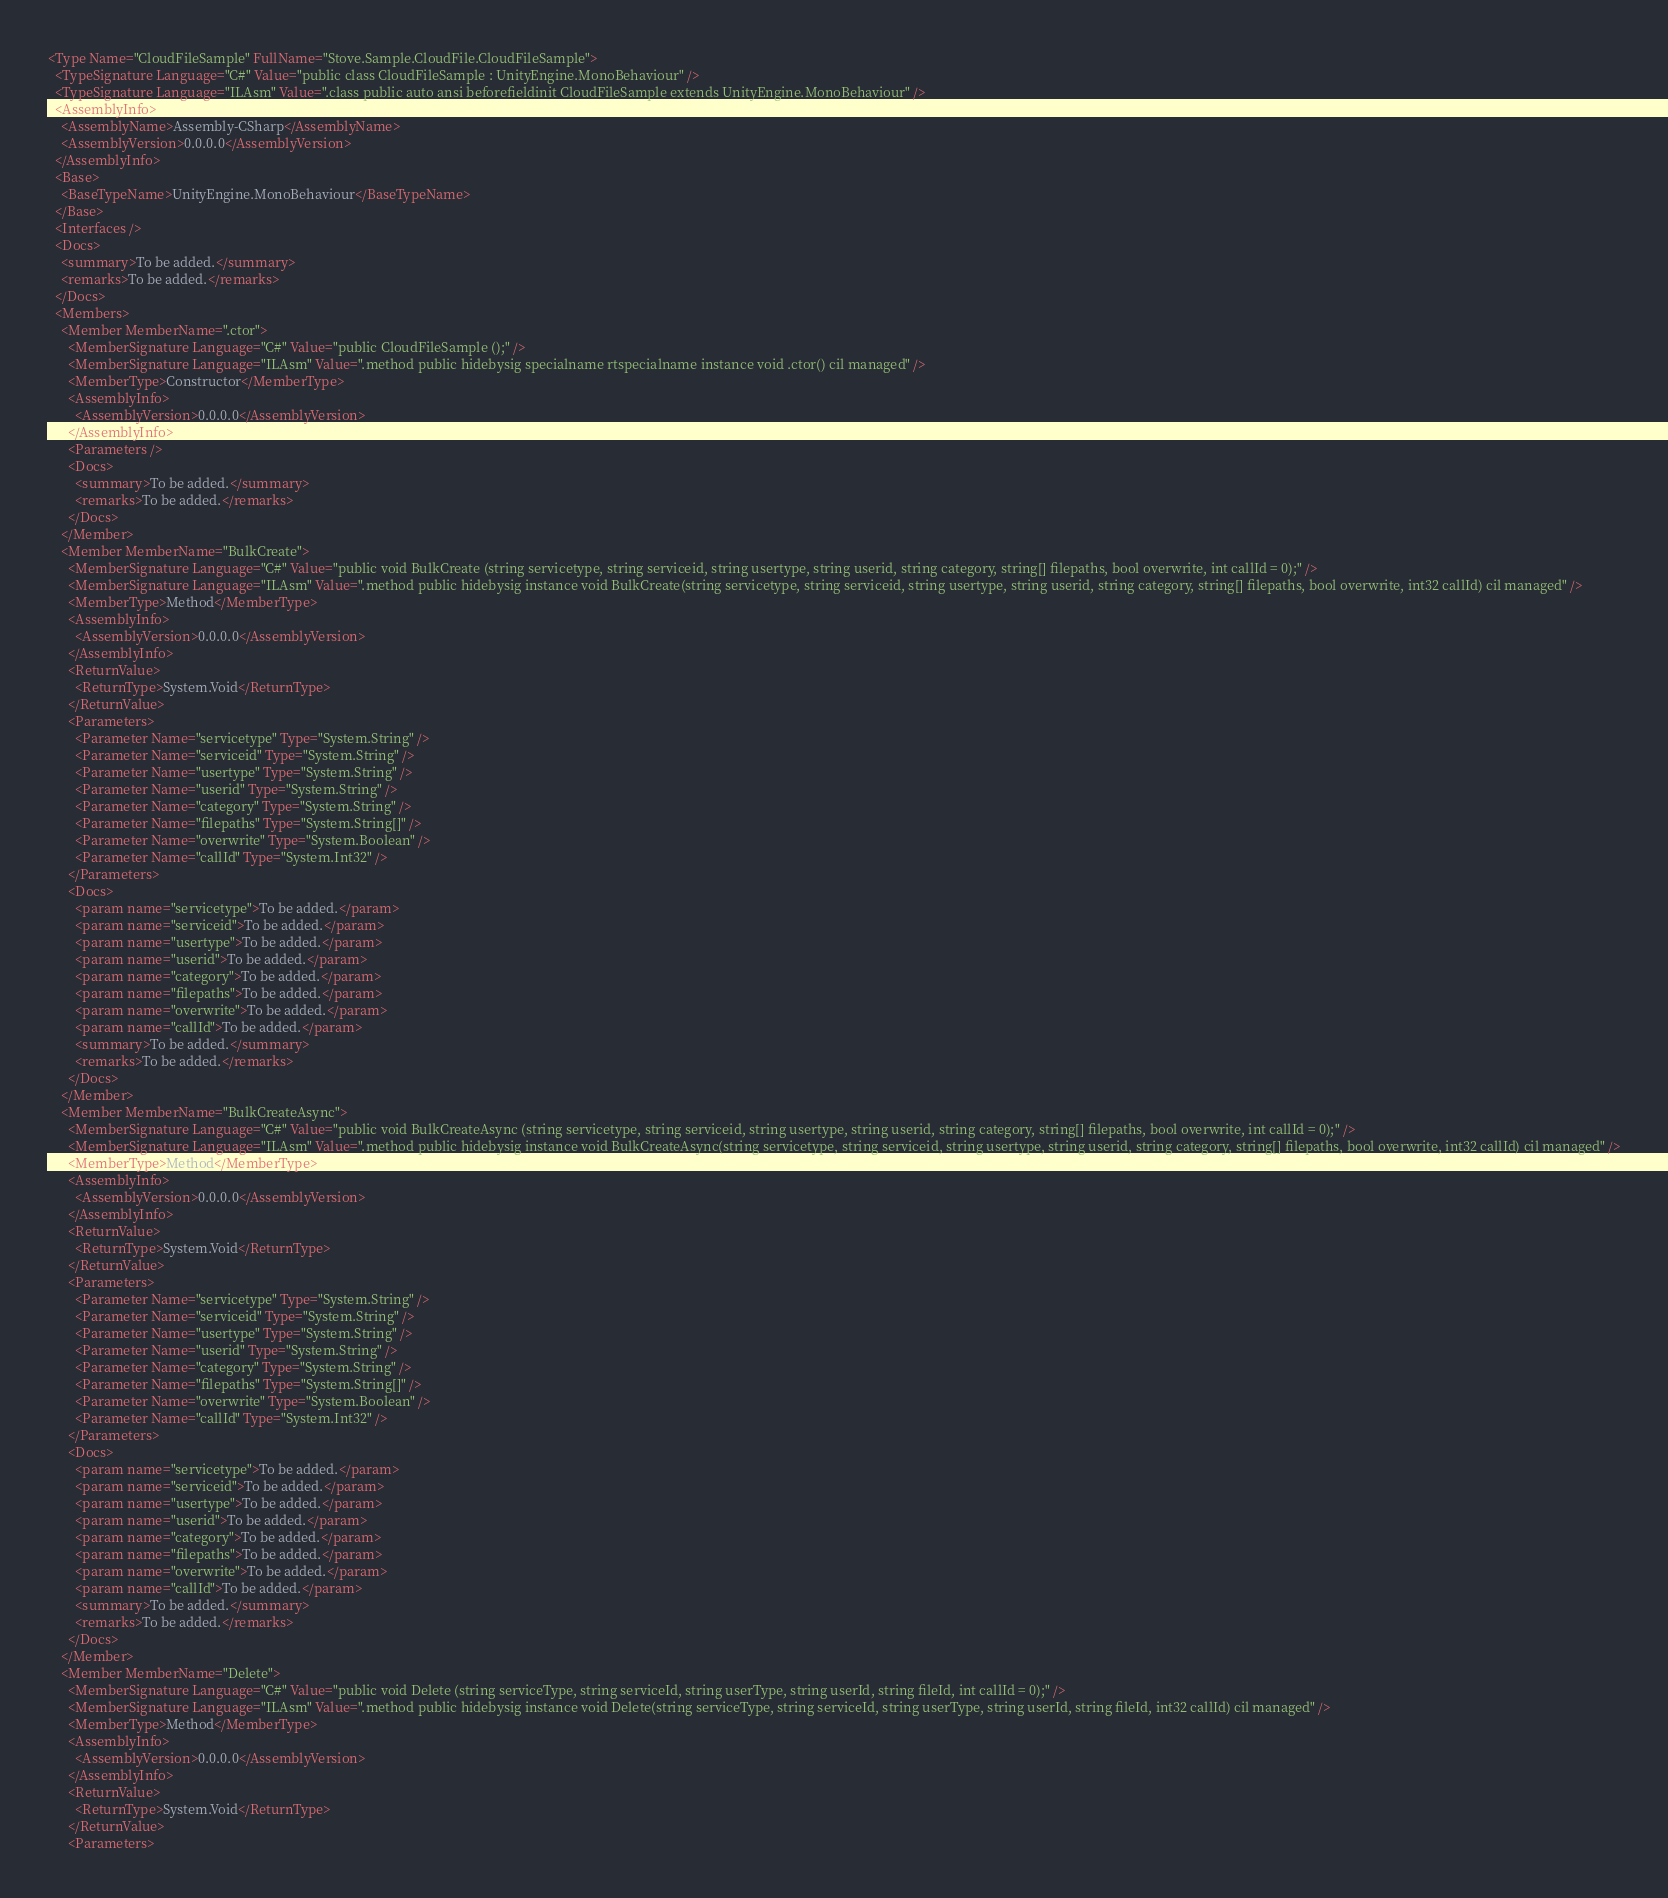Convert code to text. <code><loc_0><loc_0><loc_500><loc_500><_XML_><Type Name="CloudFileSample" FullName="Stove.Sample.CloudFile.CloudFileSample">
  <TypeSignature Language="C#" Value="public class CloudFileSample : UnityEngine.MonoBehaviour" />
  <TypeSignature Language="ILAsm" Value=".class public auto ansi beforefieldinit CloudFileSample extends UnityEngine.MonoBehaviour" />
  <AssemblyInfo>
    <AssemblyName>Assembly-CSharp</AssemblyName>
    <AssemblyVersion>0.0.0.0</AssemblyVersion>
  </AssemblyInfo>
  <Base>
    <BaseTypeName>UnityEngine.MonoBehaviour</BaseTypeName>
  </Base>
  <Interfaces />
  <Docs>
    <summary>To be added.</summary>
    <remarks>To be added.</remarks>
  </Docs>
  <Members>
    <Member MemberName=".ctor">
      <MemberSignature Language="C#" Value="public CloudFileSample ();" />
      <MemberSignature Language="ILAsm" Value=".method public hidebysig specialname rtspecialname instance void .ctor() cil managed" />
      <MemberType>Constructor</MemberType>
      <AssemblyInfo>
        <AssemblyVersion>0.0.0.0</AssemblyVersion>
      </AssemblyInfo>
      <Parameters />
      <Docs>
        <summary>To be added.</summary>
        <remarks>To be added.</remarks>
      </Docs>
    </Member>
    <Member MemberName="BulkCreate">
      <MemberSignature Language="C#" Value="public void BulkCreate (string servicetype, string serviceid, string usertype, string userid, string category, string[] filepaths, bool overwrite, int callId = 0);" />
      <MemberSignature Language="ILAsm" Value=".method public hidebysig instance void BulkCreate(string servicetype, string serviceid, string usertype, string userid, string category, string[] filepaths, bool overwrite, int32 callId) cil managed" />
      <MemberType>Method</MemberType>
      <AssemblyInfo>
        <AssemblyVersion>0.0.0.0</AssemblyVersion>
      </AssemblyInfo>
      <ReturnValue>
        <ReturnType>System.Void</ReturnType>
      </ReturnValue>
      <Parameters>
        <Parameter Name="servicetype" Type="System.String" />
        <Parameter Name="serviceid" Type="System.String" />
        <Parameter Name="usertype" Type="System.String" />
        <Parameter Name="userid" Type="System.String" />
        <Parameter Name="category" Type="System.String" />
        <Parameter Name="filepaths" Type="System.String[]" />
        <Parameter Name="overwrite" Type="System.Boolean" />
        <Parameter Name="callId" Type="System.Int32" />
      </Parameters>
      <Docs>
        <param name="servicetype">To be added.</param>
        <param name="serviceid">To be added.</param>
        <param name="usertype">To be added.</param>
        <param name="userid">To be added.</param>
        <param name="category">To be added.</param>
        <param name="filepaths">To be added.</param>
        <param name="overwrite">To be added.</param>
        <param name="callId">To be added.</param>
        <summary>To be added.</summary>
        <remarks>To be added.</remarks>
      </Docs>
    </Member>
    <Member MemberName="BulkCreateAsync">
      <MemberSignature Language="C#" Value="public void BulkCreateAsync (string servicetype, string serviceid, string usertype, string userid, string category, string[] filepaths, bool overwrite, int callId = 0);" />
      <MemberSignature Language="ILAsm" Value=".method public hidebysig instance void BulkCreateAsync(string servicetype, string serviceid, string usertype, string userid, string category, string[] filepaths, bool overwrite, int32 callId) cil managed" />
      <MemberType>Method</MemberType>
      <AssemblyInfo>
        <AssemblyVersion>0.0.0.0</AssemblyVersion>
      </AssemblyInfo>
      <ReturnValue>
        <ReturnType>System.Void</ReturnType>
      </ReturnValue>
      <Parameters>
        <Parameter Name="servicetype" Type="System.String" />
        <Parameter Name="serviceid" Type="System.String" />
        <Parameter Name="usertype" Type="System.String" />
        <Parameter Name="userid" Type="System.String" />
        <Parameter Name="category" Type="System.String" />
        <Parameter Name="filepaths" Type="System.String[]" />
        <Parameter Name="overwrite" Type="System.Boolean" />
        <Parameter Name="callId" Type="System.Int32" />
      </Parameters>
      <Docs>
        <param name="servicetype">To be added.</param>
        <param name="serviceid">To be added.</param>
        <param name="usertype">To be added.</param>
        <param name="userid">To be added.</param>
        <param name="category">To be added.</param>
        <param name="filepaths">To be added.</param>
        <param name="overwrite">To be added.</param>
        <param name="callId">To be added.</param>
        <summary>To be added.</summary>
        <remarks>To be added.</remarks>
      </Docs>
    </Member>
    <Member MemberName="Delete">
      <MemberSignature Language="C#" Value="public void Delete (string serviceType, string serviceId, string userType, string userId, string fileId, int callId = 0);" />
      <MemberSignature Language="ILAsm" Value=".method public hidebysig instance void Delete(string serviceType, string serviceId, string userType, string userId, string fileId, int32 callId) cil managed" />
      <MemberType>Method</MemberType>
      <AssemblyInfo>
        <AssemblyVersion>0.0.0.0</AssemblyVersion>
      </AssemblyInfo>
      <ReturnValue>
        <ReturnType>System.Void</ReturnType>
      </ReturnValue>
      <Parameters></code> 